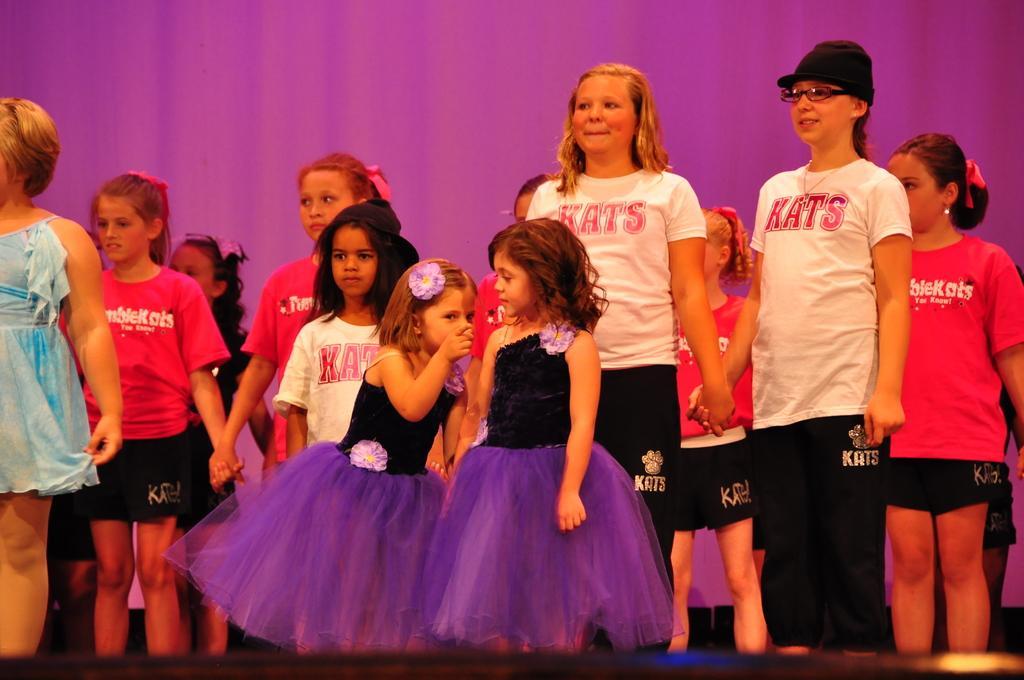In one or two sentences, can you explain what this image depicts? In this image I can see a group of people standing and wearing different color dresses. Background is in purple color. 